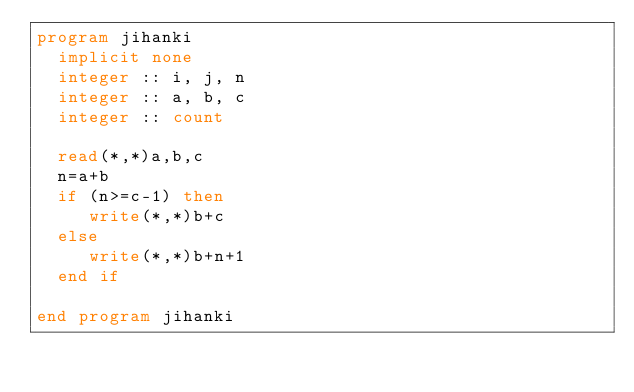<code> <loc_0><loc_0><loc_500><loc_500><_FORTRAN_>program jihanki
  implicit none
  integer :: i, j, n
  integer :: a, b, c
  integer :: count

  read(*,*)a,b,c
  n=a+b
  if (n>=c-1) then
     write(*,*)b+c
  else
     write(*,*)b+n+1
  end if
  
end program jihanki</code> 